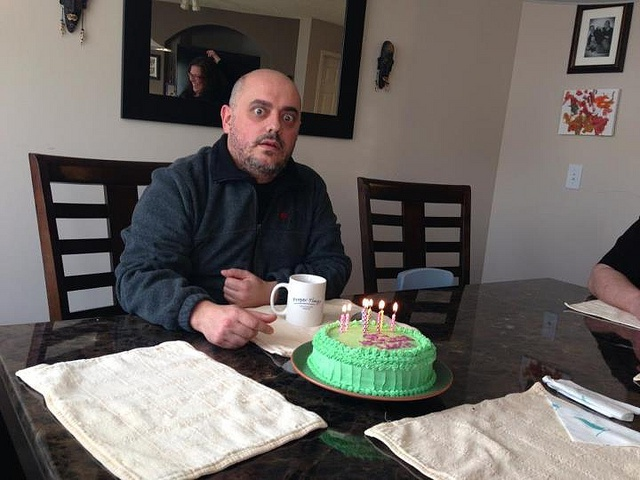Describe the objects in this image and their specific colors. I can see dining table in darkgray, black, and gray tones, people in darkgray, black, brown, and lightpink tones, chair in darkgray, black, maroon, and gray tones, chair in darkgray, black, and gray tones, and cake in darkgray, lightgreen, green, and aquamarine tones in this image. 